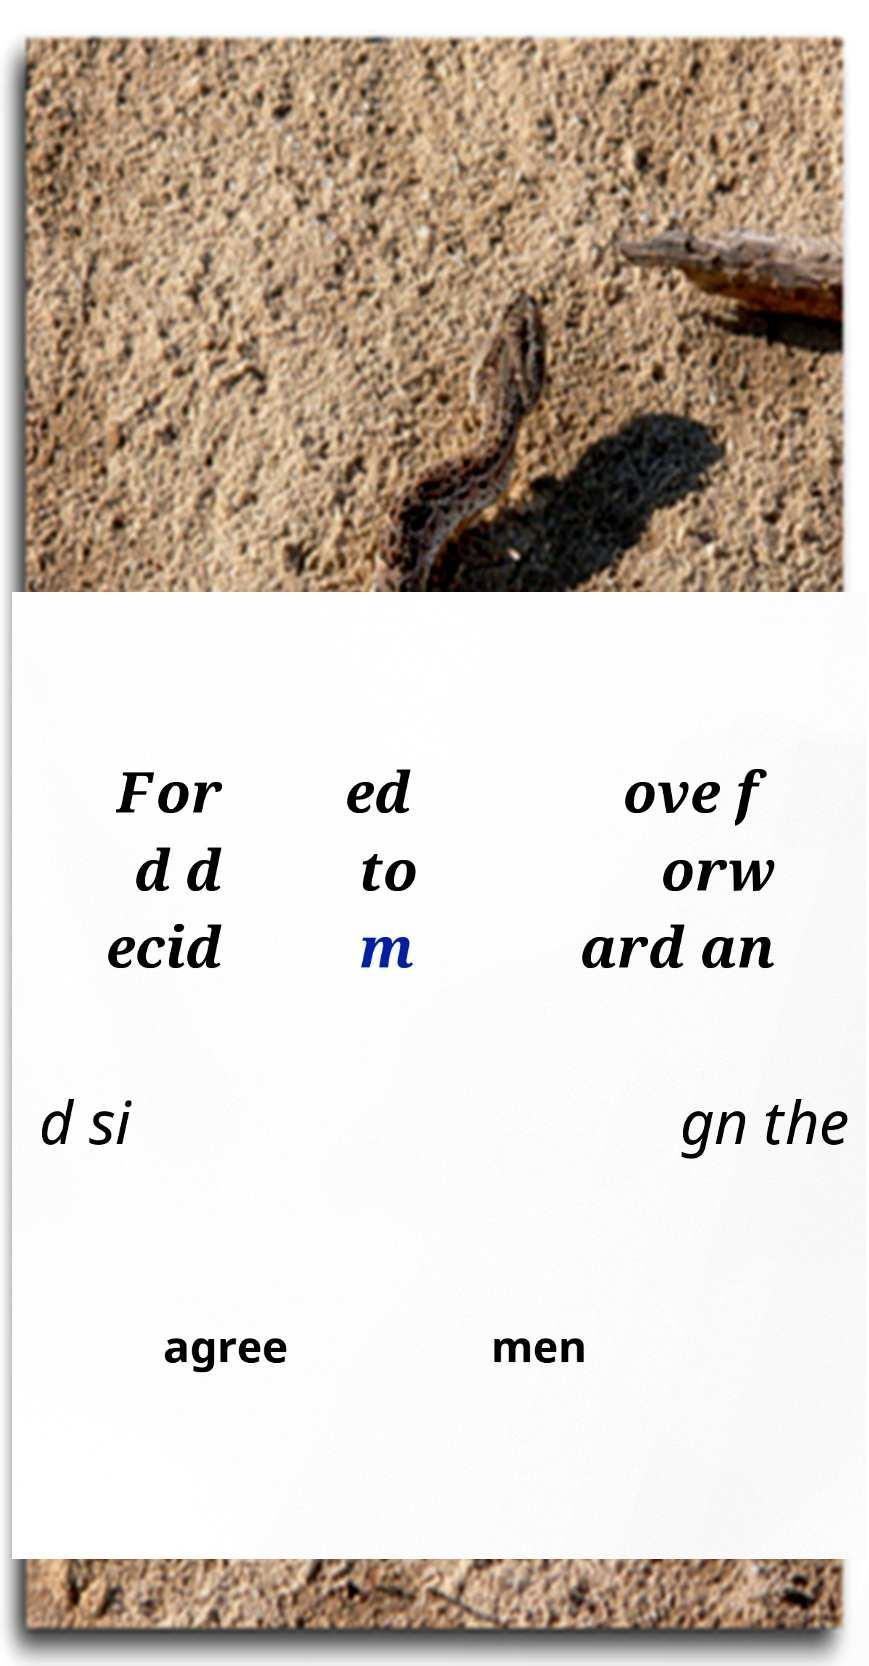Please identify and transcribe the text found in this image. For d d ecid ed to m ove f orw ard an d si gn the agree men 